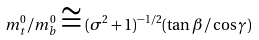Convert formula to latex. <formula><loc_0><loc_0><loc_500><loc_500>m _ { t } ^ { 0 } / m _ { b } ^ { 0 } \cong ( \sigma ^ { 2 } + 1 ) ^ { - 1 / 2 } ( \tan \beta / \cos \gamma )</formula> 